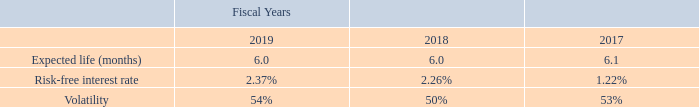Employee Stock Purchase Plan
The weighted average estimated fair value, as defined by the amended authoritative guidance, of rights issued pursuant to the Company’s ESPP during 2019, 2018 and 2017 was $4.28, $5.18 and $6.02, respectively. Sales under the ESPP were 24,131 shares of common stock at an average price per share of $9.76 for 2019, 31,306 shares of common stock at an average price per share of $15.40 for 2018, and 38,449 shares of common stock at an average price per share of $12.04 for 2017.
As of December 29, 2019, 62,335 shares under the 2009 ESPP remained available for issuance. The Company recorded compensation expenses related to the ESPP of $60,000, $205,000 and $153,000 in 2019, 2018 and 2017, respectively.
The fair value of rights issued pursuant to the Company’s ESPP was estimated on the commencement date of each offering period using the following weighted average assumptions:
The methodologies for determining the above values were as follows:
• Expected term: The expected term represents the length of the purchase period contained in the ESPP.
• Risk-free interest rate: The risk-free interest rate assumption is based upon the risk-free rate of a Treasury Constant Maturity bond with a maturity appropriate for the term of the purchase period.
• Volatility: The Company determines expected volatility based on historical volatility of the Company’s common stock for the term of the purchase period.
• Dividend Yield: The expected dividend assumption is based on the Company’s intent not to issue a dividend under its dividend policy.
What are the respective weighted average estimated fair value of the company's ESPP during 2019 and 2018? $4.28, $5.18. What are the respective weighted average estimated fair value of the company's ESPP during 2018 and 2017? $5.18, $6.02. What are the respective compensation expenses related to the ESPP in 2019 and 2018 respectively? $60,000, $205,000. What is the average risk-free interest rate of the company's ESPP in 2017 and 2018?
Answer scale should be: percent. (1.22 + 2.26)/2 
Answer: 1.74. What is the average risk-free interest rate of the company's ESPP in 2018 and 2019?
Answer scale should be: percent. (2.26 + 2.37)/2 
Answer: 2.32. What is the average volatility of the company's ESPP in 2018 and 2019?
Answer scale should be: percent. (54 + 50)/2 
Answer: 52. 